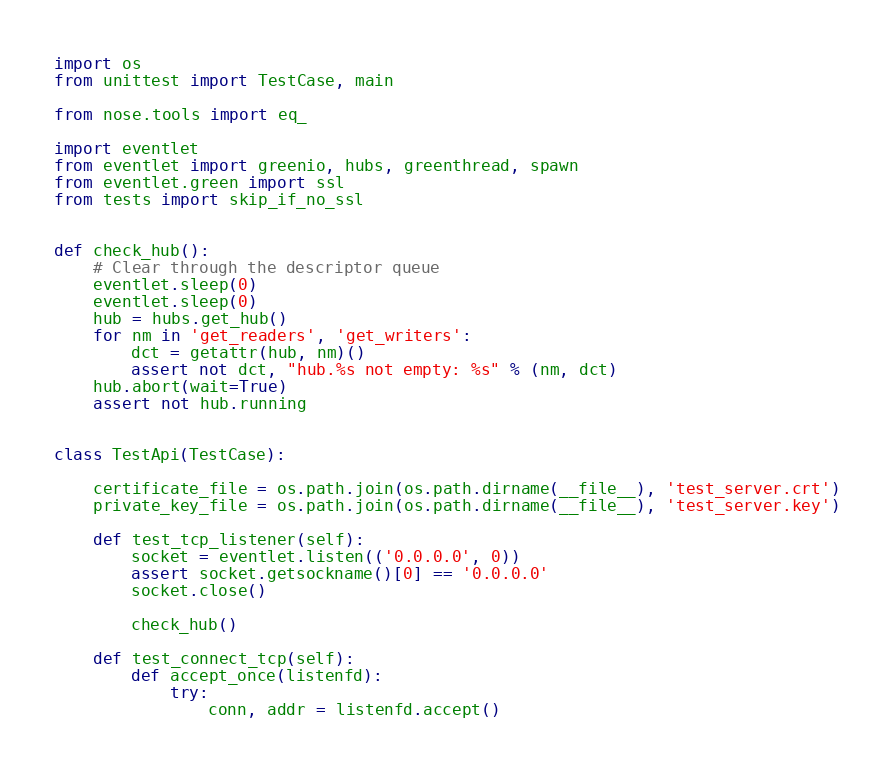Convert code to text. <code><loc_0><loc_0><loc_500><loc_500><_Python_>import os
from unittest import TestCase, main

from nose.tools import eq_

import eventlet
from eventlet import greenio, hubs, greenthread, spawn
from eventlet.green import ssl
from tests import skip_if_no_ssl


def check_hub():
    # Clear through the descriptor queue
    eventlet.sleep(0)
    eventlet.sleep(0)
    hub = hubs.get_hub()
    for nm in 'get_readers', 'get_writers':
        dct = getattr(hub, nm)()
        assert not dct, "hub.%s not empty: %s" % (nm, dct)
    hub.abort(wait=True)
    assert not hub.running


class TestApi(TestCase):

    certificate_file = os.path.join(os.path.dirname(__file__), 'test_server.crt')
    private_key_file = os.path.join(os.path.dirname(__file__), 'test_server.key')

    def test_tcp_listener(self):
        socket = eventlet.listen(('0.0.0.0', 0))
        assert socket.getsockname()[0] == '0.0.0.0'
        socket.close()

        check_hub()

    def test_connect_tcp(self):
        def accept_once(listenfd):
            try:
                conn, addr = listenfd.accept()</code> 